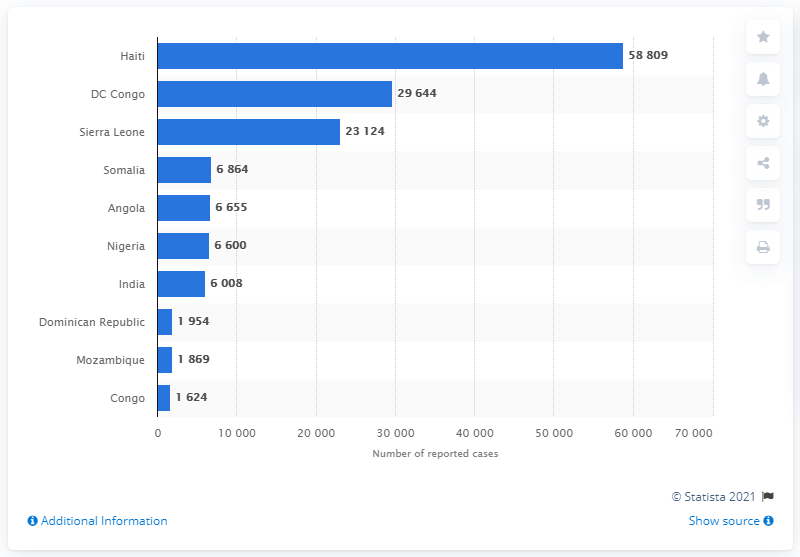Specify some key components in this picture. Haiti reported the highest number of cholera cases among all countries in 2020. 